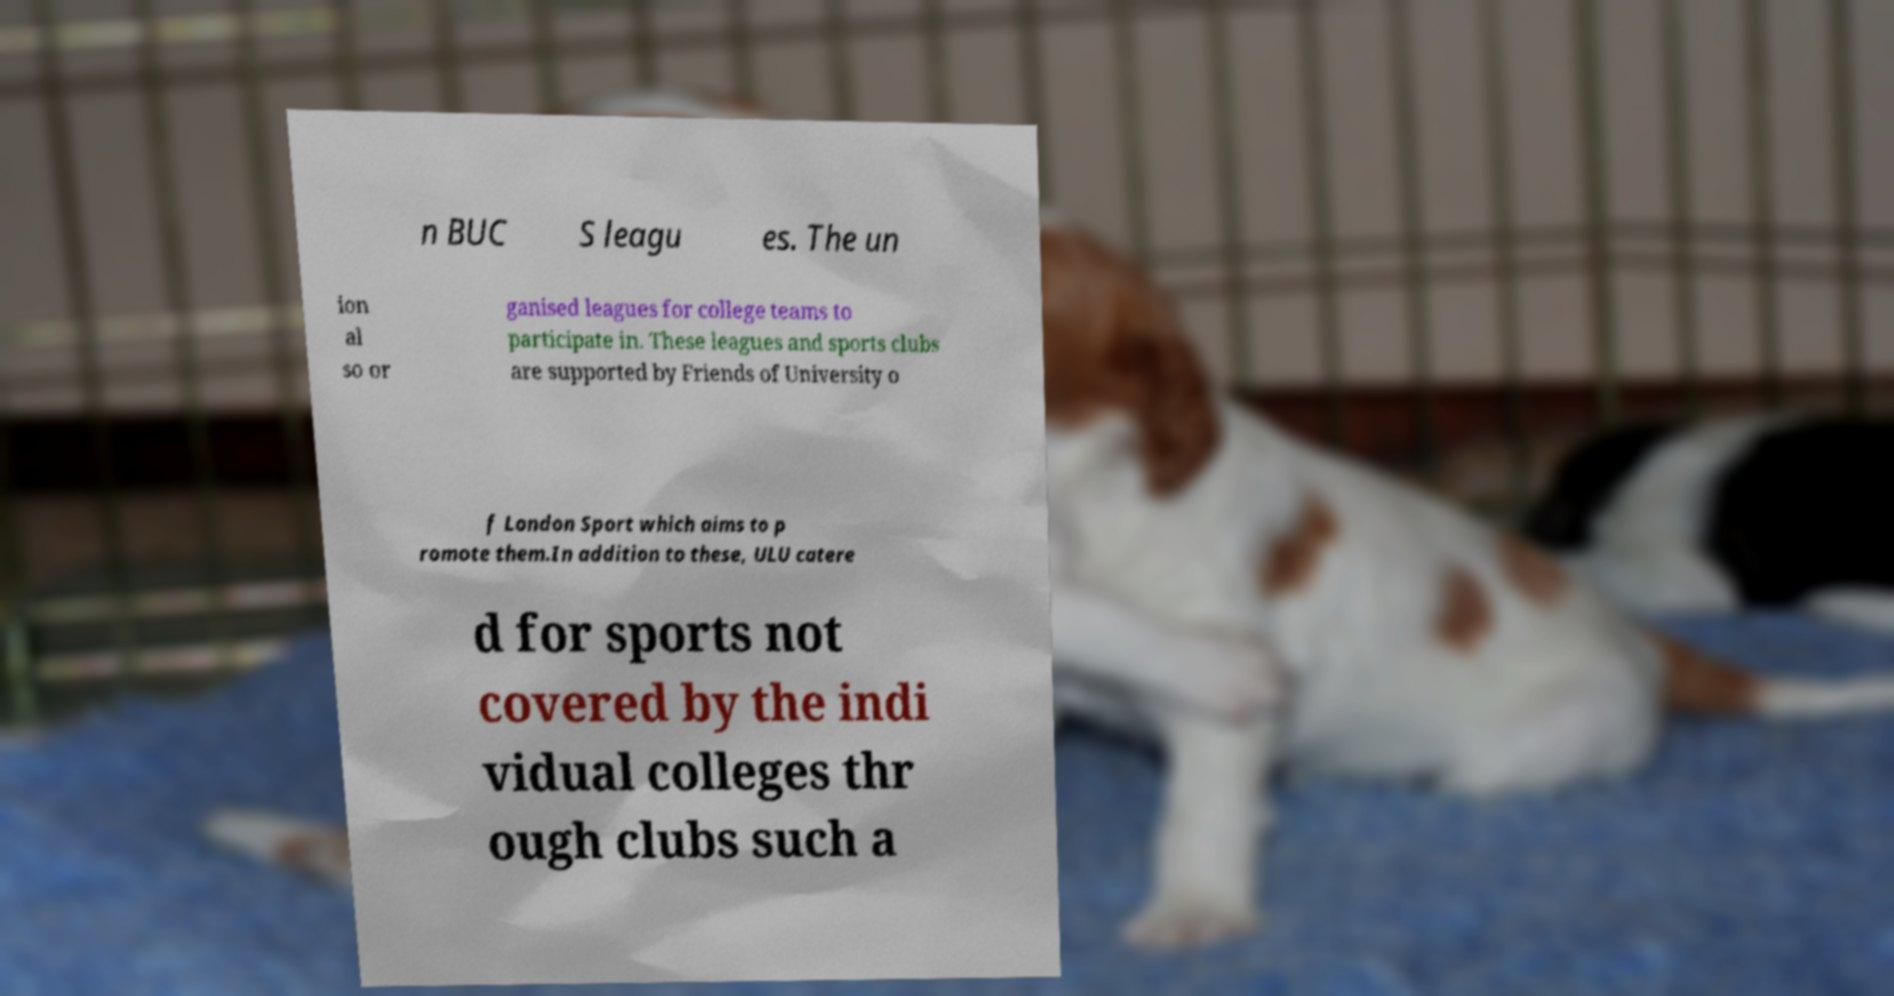Can you accurately transcribe the text from the provided image for me? n BUC S leagu es. The un ion al so or ganised leagues for college teams to participate in. These leagues and sports clubs are supported by Friends of University o f London Sport which aims to p romote them.In addition to these, ULU catere d for sports not covered by the indi vidual colleges thr ough clubs such a 